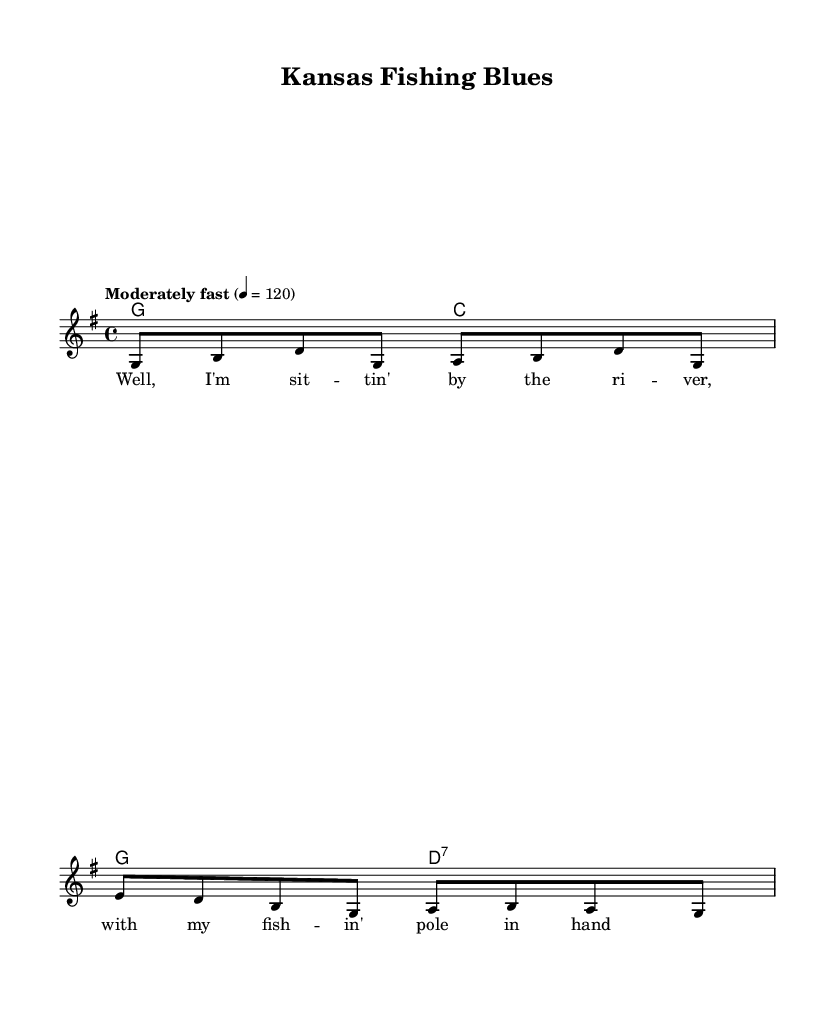What is the key signature of this music? The key signature is G major, which has one sharp (F#). This is identified at the beginning of the music sheet where the key signature is indicated.
Answer: G major What is the time signature of this piece? The time signature is 4/4. This can be found at the beginning of the sheet music, where the numerator (4) indicates four beats per measure, and the denominator (4) indicates each beat is a quarter note.
Answer: 4/4 What is the tempo marking for the song? The tempo marking is "Moderately fast" with a tempo of 120 beats per minute. This is specified on the sheet music in the tempo section.
Answer: Moderately fast 4 = 120 How many measures are in the melody? There are four measures in the melody. This can be determined by counting the groupings of notes and rests in the melody line.
Answer: 4 What chords are used in the harmonies? The chords used are G and C for the first measure and G and D7 for the second measure. These can be seen in the chord section of the sheet music, where the chord names are indicated above the melody.
Answer: G, C, D7 What is the first line of the lyrics? The first line of the lyrics is "Well, I'm sit -- tin' by the ri -- ver, with my fish -- in' pole in hand." This is found directly beneath the melody notes in the lyrics section.
Answer: Well, I'm sit -- tin' by the ri -- ver What does the song celebrate in its lyrics? The song celebrates fishing culture by depicting a serene scene by the river. This can be reasoned from the phrase "with my fish -- in' pole in hand," indicating an appreciation for fishing activities in a rural setting.
Answer: Fishing culture 